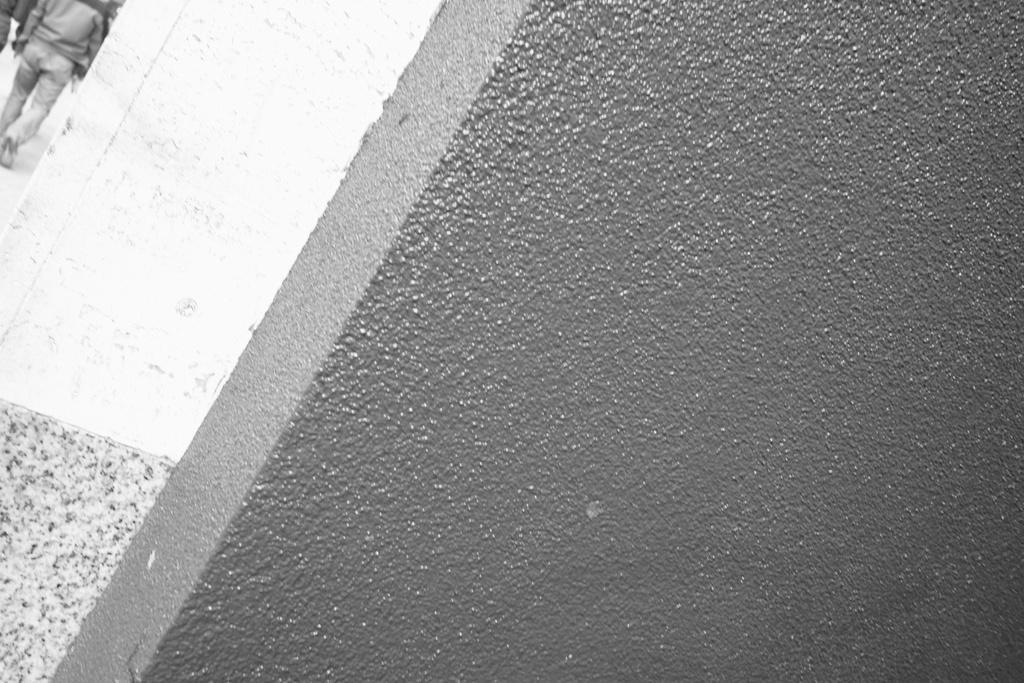Can you describe this image briefly? In the picture we can see a wall and a pillar, near to the pillar we can see a man walking on the path. 